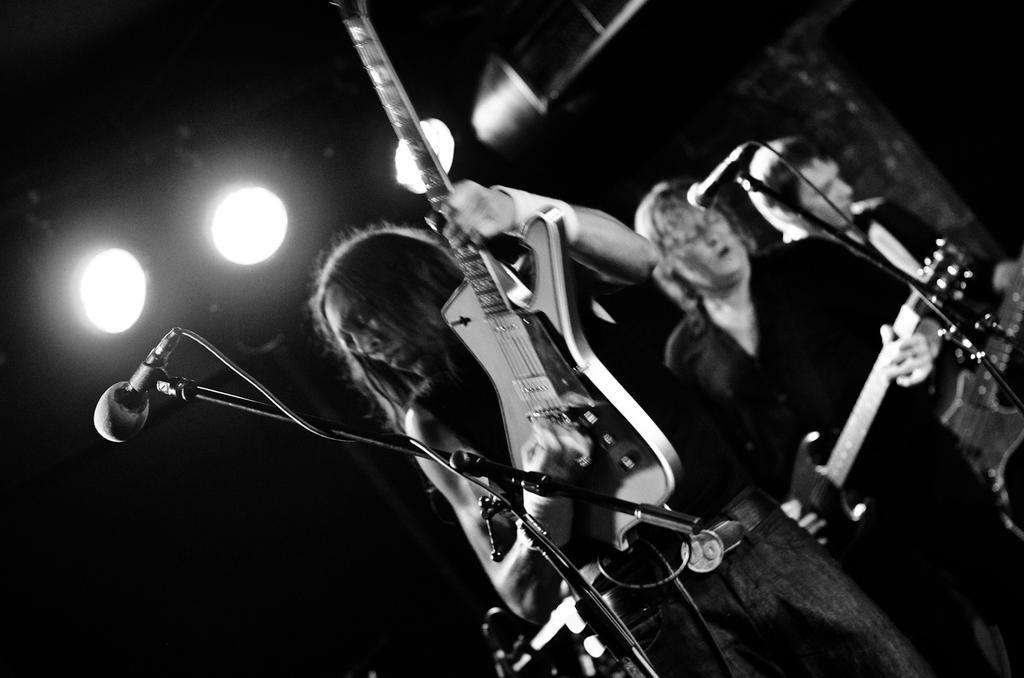How would you summarize this image in a sentence or two? In this picture there is a man who is playing a guitar. He is standing near to the mic. On the left there are two person were also playing the guitar. On the left I can see the focus lights. In the bottom left I can see the darkness. 